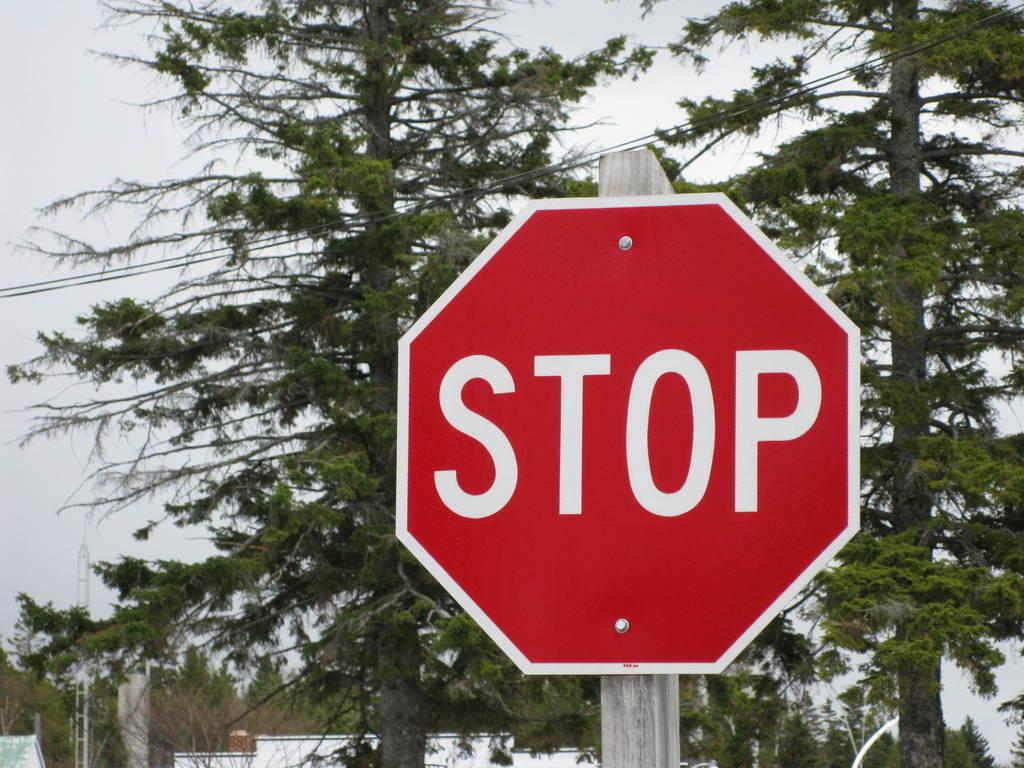<image>
Create a compact narrative representing the image presented. A red sign that says Stop has trees behind it. 